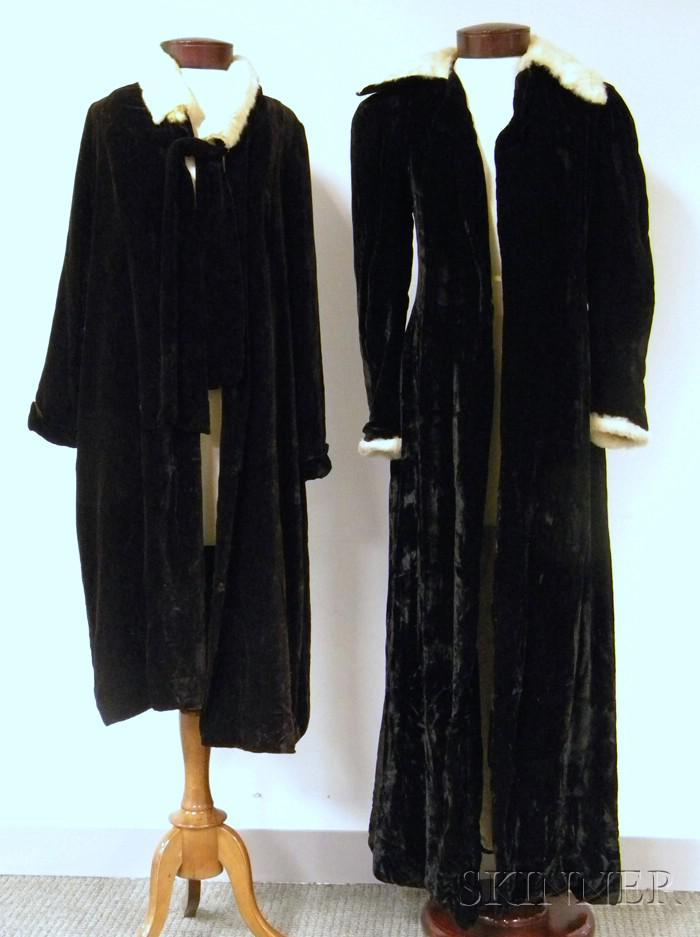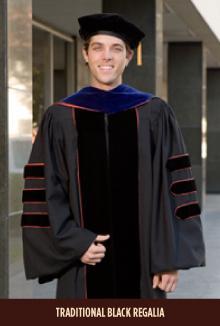The first image is the image on the left, the second image is the image on the right. Analyze the images presented: Is the assertion "An image shows exactly one black gradulation robe with white embellishments, displayed on a headless form." valid? Answer yes or no. No. The first image is the image on the left, the second image is the image on the right. Evaluate the accuracy of this statement regarding the images: "There are exactly three graduation robes, two in one image and one in the other, one or more robes does not contain people.". Is it true? Answer yes or no. Yes. 